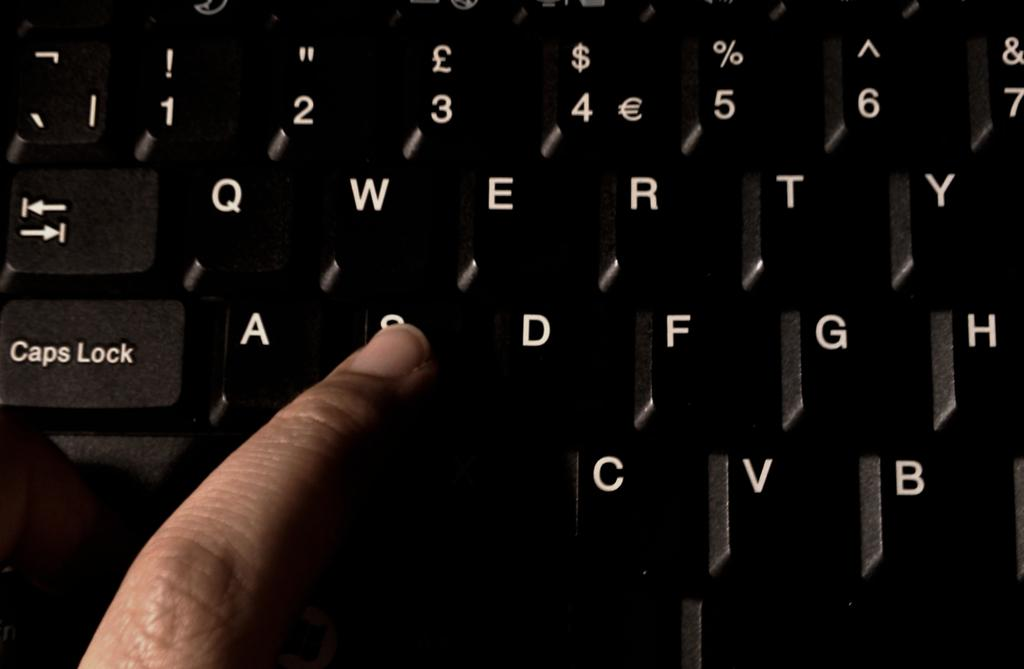<image>
Render a clear and concise summary of the photo. A persons finger on the letter S of a black keyboard. 